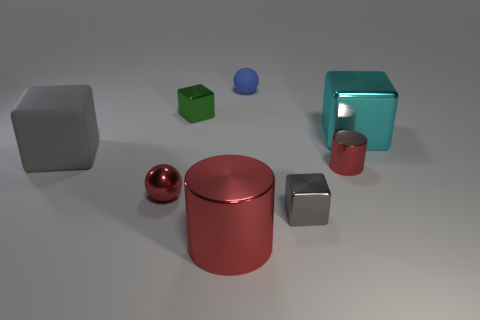Add 2 blue balls. How many objects exist? 10 Subtract all balls. How many objects are left? 6 Subtract all cyan blocks. Subtract all big cyan metal things. How many objects are left? 6 Add 1 small red objects. How many small red objects are left? 3 Add 5 big cyan metallic things. How many big cyan metallic things exist? 6 Subtract 0 blue blocks. How many objects are left? 8 